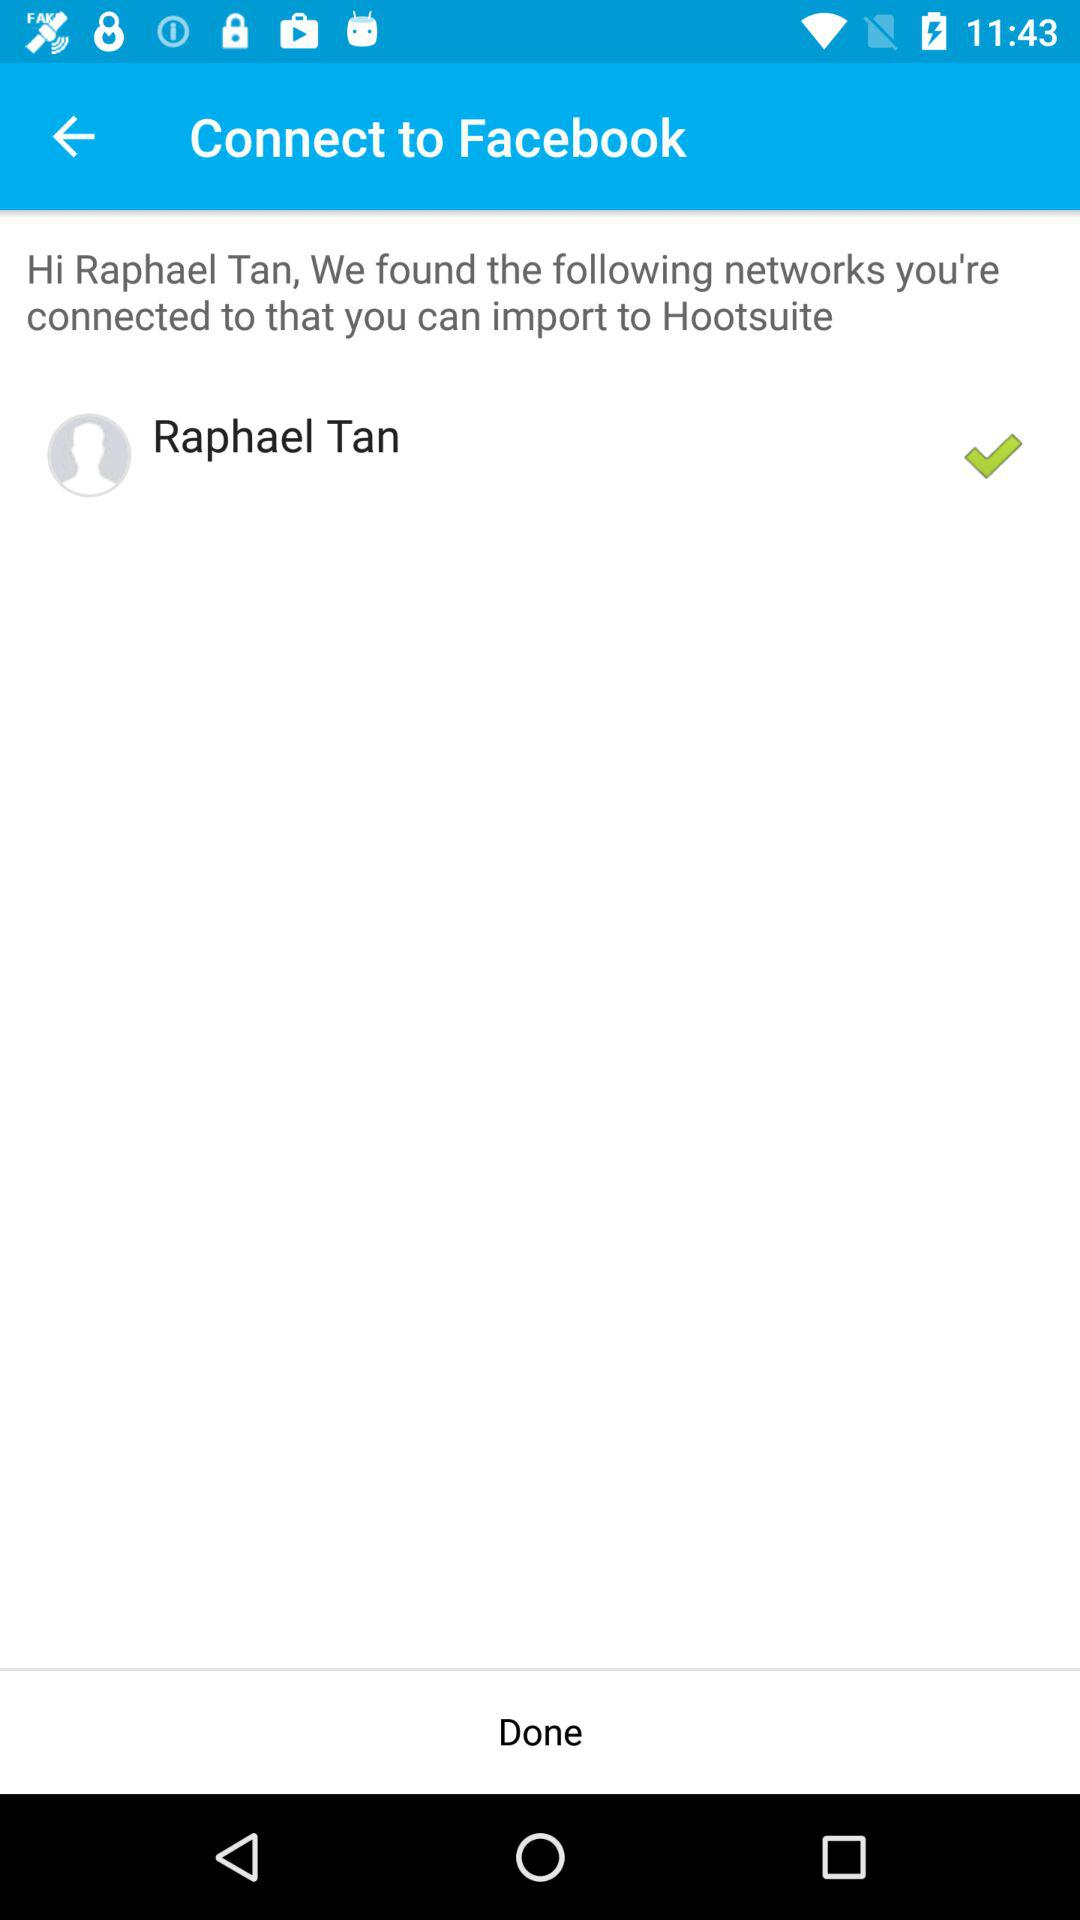How many networks are Raphael Tan connected to?
Answer the question using a single word or phrase. 1 